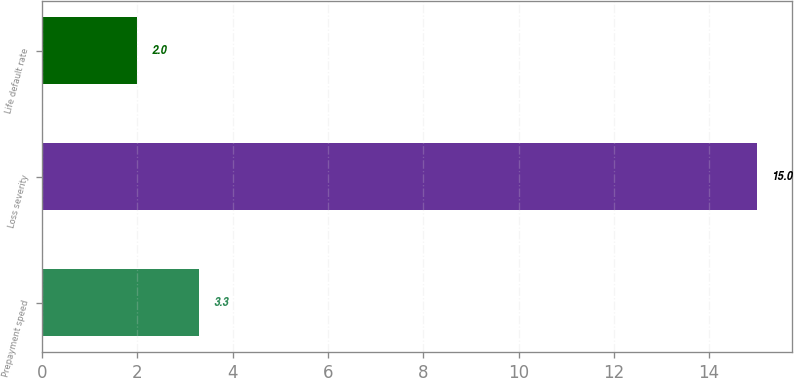Convert chart. <chart><loc_0><loc_0><loc_500><loc_500><bar_chart><fcel>Prepayment speed<fcel>Loss severity<fcel>Life default rate<nl><fcel>3.3<fcel>15<fcel>2<nl></chart> 